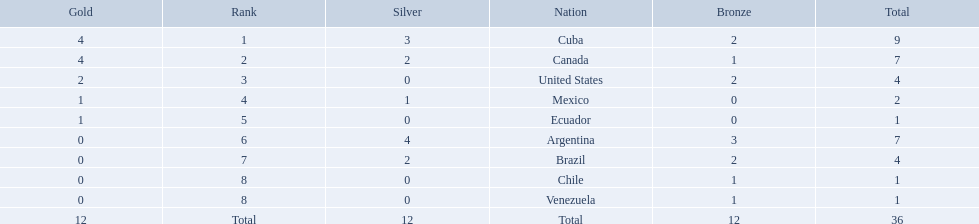Which nations won gold medals? Cuba, Canada, United States, Mexico, Ecuador. How many medals did each nation win? Cuba, 9, Canada, 7, United States, 4, Mexico, 2, Ecuador, 1. Which nation only won a gold medal? Ecuador. Which nations competed in the 2011 pan american games? Cuba, Canada, United States, Mexico, Ecuador, Argentina, Brazil, Chile, Venezuela. Of these nations which ones won gold? Cuba, Canada, United States, Mexico, Ecuador. Which nation of the ones that won gold did not win silver? United States. 